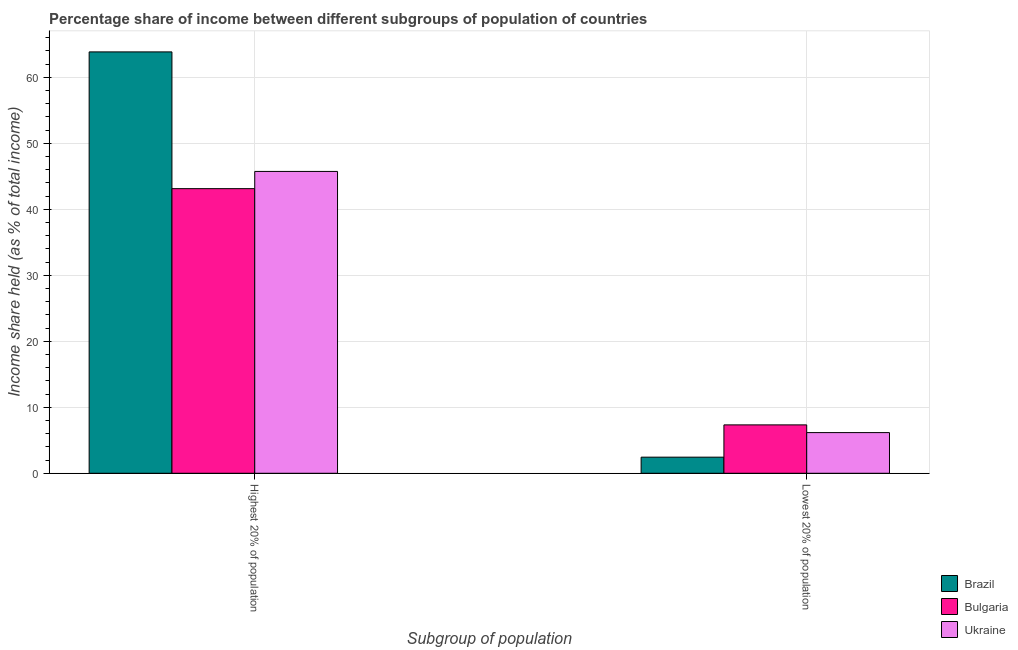How many different coloured bars are there?
Your answer should be compact. 3. How many groups of bars are there?
Offer a terse response. 2. Are the number of bars per tick equal to the number of legend labels?
Your response must be concise. Yes. Are the number of bars on each tick of the X-axis equal?
Offer a terse response. Yes. What is the label of the 2nd group of bars from the left?
Your answer should be compact. Lowest 20% of population. What is the income share held by highest 20% of the population in Bulgaria?
Offer a terse response. 43.12. Across all countries, what is the maximum income share held by highest 20% of the population?
Make the answer very short. 63.84. Across all countries, what is the minimum income share held by highest 20% of the population?
Offer a terse response. 43.12. In which country was the income share held by highest 20% of the population maximum?
Make the answer very short. Brazil. What is the total income share held by highest 20% of the population in the graph?
Ensure brevity in your answer.  152.69. What is the difference between the income share held by lowest 20% of the population in Bulgaria and that in Ukraine?
Ensure brevity in your answer.  1.17. What is the difference between the income share held by lowest 20% of the population in Ukraine and the income share held by highest 20% of the population in Bulgaria?
Ensure brevity in your answer.  -36.96. What is the average income share held by lowest 20% of the population per country?
Make the answer very short. 5.31. What is the difference between the income share held by lowest 20% of the population and income share held by highest 20% of the population in Ukraine?
Give a very brief answer. -39.57. In how many countries, is the income share held by highest 20% of the population greater than 42 %?
Your answer should be compact. 3. What is the ratio of the income share held by highest 20% of the population in Bulgaria to that in Brazil?
Your answer should be very brief. 0.68. What does the 3rd bar from the left in Highest 20% of population represents?
Offer a very short reply. Ukraine. What does the 1st bar from the right in Lowest 20% of population represents?
Provide a short and direct response. Ukraine. How many bars are there?
Keep it short and to the point. 6. How many countries are there in the graph?
Keep it short and to the point. 3. What is the difference between two consecutive major ticks on the Y-axis?
Offer a terse response. 10. Are the values on the major ticks of Y-axis written in scientific E-notation?
Ensure brevity in your answer.  No. How many legend labels are there?
Make the answer very short. 3. How are the legend labels stacked?
Provide a succinct answer. Vertical. What is the title of the graph?
Offer a terse response. Percentage share of income between different subgroups of population of countries. What is the label or title of the X-axis?
Make the answer very short. Subgroup of population. What is the label or title of the Y-axis?
Offer a terse response. Income share held (as % of total income). What is the Income share held (as % of total income) in Brazil in Highest 20% of population?
Keep it short and to the point. 63.84. What is the Income share held (as % of total income) of Bulgaria in Highest 20% of population?
Offer a terse response. 43.12. What is the Income share held (as % of total income) of Ukraine in Highest 20% of population?
Offer a very short reply. 45.73. What is the Income share held (as % of total income) of Brazil in Lowest 20% of population?
Your answer should be compact. 2.44. What is the Income share held (as % of total income) in Bulgaria in Lowest 20% of population?
Your answer should be very brief. 7.33. What is the Income share held (as % of total income) of Ukraine in Lowest 20% of population?
Offer a very short reply. 6.16. Across all Subgroup of population, what is the maximum Income share held (as % of total income) in Brazil?
Make the answer very short. 63.84. Across all Subgroup of population, what is the maximum Income share held (as % of total income) of Bulgaria?
Your answer should be compact. 43.12. Across all Subgroup of population, what is the maximum Income share held (as % of total income) in Ukraine?
Your answer should be very brief. 45.73. Across all Subgroup of population, what is the minimum Income share held (as % of total income) in Brazil?
Provide a short and direct response. 2.44. Across all Subgroup of population, what is the minimum Income share held (as % of total income) in Bulgaria?
Make the answer very short. 7.33. Across all Subgroup of population, what is the minimum Income share held (as % of total income) of Ukraine?
Your answer should be compact. 6.16. What is the total Income share held (as % of total income) in Brazil in the graph?
Make the answer very short. 66.28. What is the total Income share held (as % of total income) of Bulgaria in the graph?
Keep it short and to the point. 50.45. What is the total Income share held (as % of total income) of Ukraine in the graph?
Offer a terse response. 51.89. What is the difference between the Income share held (as % of total income) of Brazil in Highest 20% of population and that in Lowest 20% of population?
Keep it short and to the point. 61.4. What is the difference between the Income share held (as % of total income) of Bulgaria in Highest 20% of population and that in Lowest 20% of population?
Make the answer very short. 35.79. What is the difference between the Income share held (as % of total income) of Ukraine in Highest 20% of population and that in Lowest 20% of population?
Keep it short and to the point. 39.57. What is the difference between the Income share held (as % of total income) of Brazil in Highest 20% of population and the Income share held (as % of total income) of Bulgaria in Lowest 20% of population?
Ensure brevity in your answer.  56.51. What is the difference between the Income share held (as % of total income) in Brazil in Highest 20% of population and the Income share held (as % of total income) in Ukraine in Lowest 20% of population?
Offer a terse response. 57.68. What is the difference between the Income share held (as % of total income) of Bulgaria in Highest 20% of population and the Income share held (as % of total income) of Ukraine in Lowest 20% of population?
Provide a succinct answer. 36.96. What is the average Income share held (as % of total income) in Brazil per Subgroup of population?
Provide a succinct answer. 33.14. What is the average Income share held (as % of total income) of Bulgaria per Subgroup of population?
Give a very brief answer. 25.23. What is the average Income share held (as % of total income) of Ukraine per Subgroup of population?
Your response must be concise. 25.95. What is the difference between the Income share held (as % of total income) in Brazil and Income share held (as % of total income) in Bulgaria in Highest 20% of population?
Make the answer very short. 20.72. What is the difference between the Income share held (as % of total income) of Brazil and Income share held (as % of total income) of Ukraine in Highest 20% of population?
Give a very brief answer. 18.11. What is the difference between the Income share held (as % of total income) in Bulgaria and Income share held (as % of total income) in Ukraine in Highest 20% of population?
Make the answer very short. -2.61. What is the difference between the Income share held (as % of total income) in Brazil and Income share held (as % of total income) in Bulgaria in Lowest 20% of population?
Keep it short and to the point. -4.89. What is the difference between the Income share held (as % of total income) of Brazil and Income share held (as % of total income) of Ukraine in Lowest 20% of population?
Offer a terse response. -3.72. What is the difference between the Income share held (as % of total income) of Bulgaria and Income share held (as % of total income) of Ukraine in Lowest 20% of population?
Your answer should be compact. 1.17. What is the ratio of the Income share held (as % of total income) in Brazil in Highest 20% of population to that in Lowest 20% of population?
Ensure brevity in your answer.  26.16. What is the ratio of the Income share held (as % of total income) of Bulgaria in Highest 20% of population to that in Lowest 20% of population?
Make the answer very short. 5.88. What is the ratio of the Income share held (as % of total income) in Ukraine in Highest 20% of population to that in Lowest 20% of population?
Make the answer very short. 7.42. What is the difference between the highest and the second highest Income share held (as % of total income) in Brazil?
Your answer should be very brief. 61.4. What is the difference between the highest and the second highest Income share held (as % of total income) in Bulgaria?
Your response must be concise. 35.79. What is the difference between the highest and the second highest Income share held (as % of total income) in Ukraine?
Your response must be concise. 39.57. What is the difference between the highest and the lowest Income share held (as % of total income) of Brazil?
Provide a short and direct response. 61.4. What is the difference between the highest and the lowest Income share held (as % of total income) of Bulgaria?
Offer a very short reply. 35.79. What is the difference between the highest and the lowest Income share held (as % of total income) of Ukraine?
Provide a short and direct response. 39.57. 